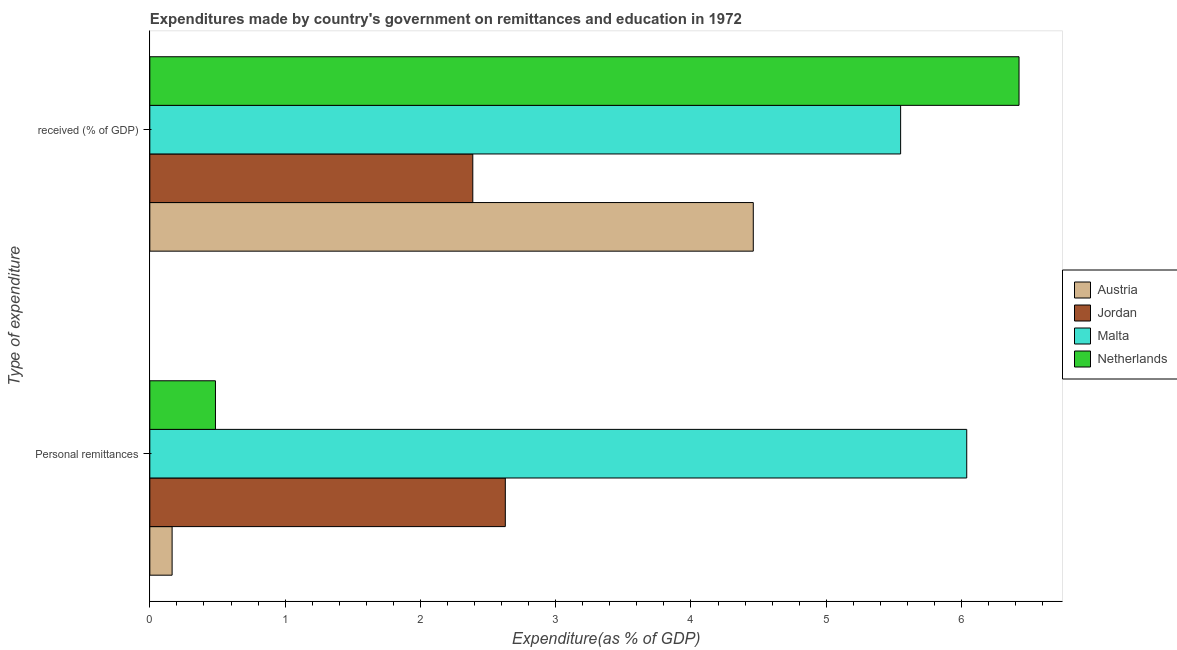How many different coloured bars are there?
Make the answer very short. 4. How many groups of bars are there?
Provide a succinct answer. 2. Are the number of bars per tick equal to the number of legend labels?
Your response must be concise. Yes. Are the number of bars on each tick of the Y-axis equal?
Offer a terse response. Yes. What is the label of the 1st group of bars from the top?
Offer a very short reply.  received (% of GDP). What is the expenditure in education in Jordan?
Provide a succinct answer. 2.39. Across all countries, what is the maximum expenditure in personal remittances?
Keep it short and to the point. 6.04. Across all countries, what is the minimum expenditure in education?
Offer a terse response. 2.39. In which country was the expenditure in personal remittances minimum?
Keep it short and to the point. Austria. What is the total expenditure in education in the graph?
Your response must be concise. 18.82. What is the difference between the expenditure in personal remittances in Jordan and that in Malta?
Your response must be concise. -3.41. What is the difference between the expenditure in education in Malta and the expenditure in personal remittances in Austria?
Offer a terse response. 5.39. What is the average expenditure in education per country?
Provide a succinct answer. 4.71. What is the difference between the expenditure in education and expenditure in personal remittances in Jordan?
Provide a succinct answer. -0.24. What is the ratio of the expenditure in education in Jordan to that in Netherlands?
Make the answer very short. 0.37. Is the expenditure in personal remittances in Austria less than that in Jordan?
Your answer should be very brief. Yes. What does the 4th bar from the bottom in Personal remittances represents?
Keep it short and to the point. Netherlands. Are all the bars in the graph horizontal?
Your answer should be compact. Yes. What is the difference between two consecutive major ticks on the X-axis?
Offer a terse response. 1. How many legend labels are there?
Offer a very short reply. 4. What is the title of the graph?
Your answer should be compact. Expenditures made by country's government on remittances and education in 1972. What is the label or title of the X-axis?
Your response must be concise. Expenditure(as % of GDP). What is the label or title of the Y-axis?
Your response must be concise. Type of expenditure. What is the Expenditure(as % of GDP) in Austria in Personal remittances?
Offer a terse response. 0.16. What is the Expenditure(as % of GDP) of Jordan in Personal remittances?
Make the answer very short. 2.63. What is the Expenditure(as % of GDP) of Malta in Personal remittances?
Your answer should be very brief. 6.04. What is the Expenditure(as % of GDP) in Netherlands in Personal remittances?
Keep it short and to the point. 0.49. What is the Expenditure(as % of GDP) in Austria in  received (% of GDP)?
Provide a succinct answer. 4.46. What is the Expenditure(as % of GDP) in Jordan in  received (% of GDP)?
Give a very brief answer. 2.39. What is the Expenditure(as % of GDP) of Malta in  received (% of GDP)?
Keep it short and to the point. 5.55. What is the Expenditure(as % of GDP) of Netherlands in  received (% of GDP)?
Give a very brief answer. 6.43. Across all Type of expenditure, what is the maximum Expenditure(as % of GDP) of Austria?
Provide a short and direct response. 4.46. Across all Type of expenditure, what is the maximum Expenditure(as % of GDP) of Jordan?
Your answer should be very brief. 2.63. Across all Type of expenditure, what is the maximum Expenditure(as % of GDP) in Malta?
Provide a short and direct response. 6.04. Across all Type of expenditure, what is the maximum Expenditure(as % of GDP) in Netherlands?
Your answer should be very brief. 6.43. Across all Type of expenditure, what is the minimum Expenditure(as % of GDP) of Austria?
Offer a very short reply. 0.16. Across all Type of expenditure, what is the minimum Expenditure(as % of GDP) in Jordan?
Keep it short and to the point. 2.39. Across all Type of expenditure, what is the minimum Expenditure(as % of GDP) of Malta?
Ensure brevity in your answer.  5.55. Across all Type of expenditure, what is the minimum Expenditure(as % of GDP) in Netherlands?
Keep it short and to the point. 0.49. What is the total Expenditure(as % of GDP) of Austria in the graph?
Keep it short and to the point. 4.63. What is the total Expenditure(as % of GDP) of Jordan in the graph?
Your answer should be compact. 5.02. What is the total Expenditure(as % of GDP) of Malta in the graph?
Make the answer very short. 11.59. What is the total Expenditure(as % of GDP) of Netherlands in the graph?
Ensure brevity in your answer.  6.91. What is the difference between the Expenditure(as % of GDP) of Austria in Personal remittances and that in  received (% of GDP)?
Your answer should be very brief. -4.3. What is the difference between the Expenditure(as % of GDP) in Jordan in Personal remittances and that in  received (% of GDP)?
Your answer should be very brief. 0.24. What is the difference between the Expenditure(as % of GDP) of Malta in Personal remittances and that in  received (% of GDP)?
Give a very brief answer. 0.49. What is the difference between the Expenditure(as % of GDP) in Netherlands in Personal remittances and that in  received (% of GDP)?
Make the answer very short. -5.94. What is the difference between the Expenditure(as % of GDP) in Austria in Personal remittances and the Expenditure(as % of GDP) in Jordan in  received (% of GDP)?
Your answer should be compact. -2.22. What is the difference between the Expenditure(as % of GDP) in Austria in Personal remittances and the Expenditure(as % of GDP) in Malta in  received (% of GDP)?
Your response must be concise. -5.39. What is the difference between the Expenditure(as % of GDP) in Austria in Personal remittances and the Expenditure(as % of GDP) in Netherlands in  received (% of GDP)?
Provide a succinct answer. -6.26. What is the difference between the Expenditure(as % of GDP) in Jordan in Personal remittances and the Expenditure(as % of GDP) in Malta in  received (% of GDP)?
Offer a very short reply. -2.92. What is the difference between the Expenditure(as % of GDP) of Jordan in Personal remittances and the Expenditure(as % of GDP) of Netherlands in  received (% of GDP)?
Provide a short and direct response. -3.8. What is the difference between the Expenditure(as % of GDP) of Malta in Personal remittances and the Expenditure(as % of GDP) of Netherlands in  received (% of GDP)?
Your answer should be very brief. -0.39. What is the average Expenditure(as % of GDP) of Austria per Type of expenditure?
Your answer should be compact. 2.31. What is the average Expenditure(as % of GDP) in Jordan per Type of expenditure?
Your response must be concise. 2.51. What is the average Expenditure(as % of GDP) of Malta per Type of expenditure?
Give a very brief answer. 5.79. What is the average Expenditure(as % of GDP) of Netherlands per Type of expenditure?
Offer a terse response. 3.46. What is the difference between the Expenditure(as % of GDP) in Austria and Expenditure(as % of GDP) in Jordan in Personal remittances?
Keep it short and to the point. -2.46. What is the difference between the Expenditure(as % of GDP) of Austria and Expenditure(as % of GDP) of Malta in Personal remittances?
Your response must be concise. -5.87. What is the difference between the Expenditure(as % of GDP) in Austria and Expenditure(as % of GDP) in Netherlands in Personal remittances?
Provide a succinct answer. -0.32. What is the difference between the Expenditure(as % of GDP) of Jordan and Expenditure(as % of GDP) of Malta in Personal remittances?
Keep it short and to the point. -3.41. What is the difference between the Expenditure(as % of GDP) in Jordan and Expenditure(as % of GDP) in Netherlands in Personal remittances?
Your answer should be compact. 2.14. What is the difference between the Expenditure(as % of GDP) of Malta and Expenditure(as % of GDP) of Netherlands in Personal remittances?
Your answer should be very brief. 5.55. What is the difference between the Expenditure(as % of GDP) of Austria and Expenditure(as % of GDP) of Jordan in  received (% of GDP)?
Keep it short and to the point. 2.07. What is the difference between the Expenditure(as % of GDP) in Austria and Expenditure(as % of GDP) in Malta in  received (% of GDP)?
Your answer should be very brief. -1.09. What is the difference between the Expenditure(as % of GDP) of Austria and Expenditure(as % of GDP) of Netherlands in  received (% of GDP)?
Ensure brevity in your answer.  -1.96. What is the difference between the Expenditure(as % of GDP) in Jordan and Expenditure(as % of GDP) in Malta in  received (% of GDP)?
Provide a short and direct response. -3.16. What is the difference between the Expenditure(as % of GDP) of Jordan and Expenditure(as % of GDP) of Netherlands in  received (% of GDP)?
Ensure brevity in your answer.  -4.04. What is the difference between the Expenditure(as % of GDP) in Malta and Expenditure(as % of GDP) in Netherlands in  received (% of GDP)?
Make the answer very short. -0.88. What is the ratio of the Expenditure(as % of GDP) in Austria in Personal remittances to that in  received (% of GDP)?
Your answer should be very brief. 0.04. What is the ratio of the Expenditure(as % of GDP) in Jordan in Personal remittances to that in  received (% of GDP)?
Offer a terse response. 1.1. What is the ratio of the Expenditure(as % of GDP) of Malta in Personal remittances to that in  received (% of GDP)?
Provide a short and direct response. 1.09. What is the ratio of the Expenditure(as % of GDP) of Netherlands in Personal remittances to that in  received (% of GDP)?
Offer a terse response. 0.08. What is the difference between the highest and the second highest Expenditure(as % of GDP) in Austria?
Your answer should be very brief. 4.3. What is the difference between the highest and the second highest Expenditure(as % of GDP) in Jordan?
Keep it short and to the point. 0.24. What is the difference between the highest and the second highest Expenditure(as % of GDP) in Malta?
Keep it short and to the point. 0.49. What is the difference between the highest and the second highest Expenditure(as % of GDP) in Netherlands?
Ensure brevity in your answer.  5.94. What is the difference between the highest and the lowest Expenditure(as % of GDP) in Austria?
Give a very brief answer. 4.3. What is the difference between the highest and the lowest Expenditure(as % of GDP) of Jordan?
Offer a very short reply. 0.24. What is the difference between the highest and the lowest Expenditure(as % of GDP) of Malta?
Keep it short and to the point. 0.49. What is the difference between the highest and the lowest Expenditure(as % of GDP) of Netherlands?
Provide a short and direct response. 5.94. 